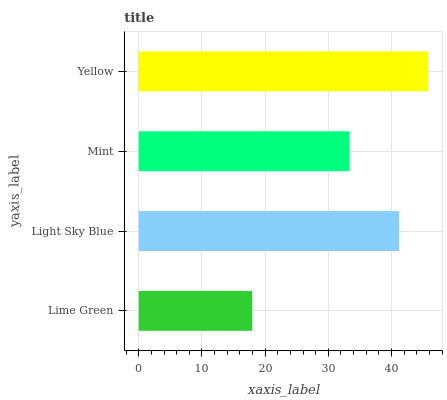Is Lime Green the minimum?
Answer yes or no. Yes. Is Yellow the maximum?
Answer yes or no. Yes. Is Light Sky Blue the minimum?
Answer yes or no. No. Is Light Sky Blue the maximum?
Answer yes or no. No. Is Light Sky Blue greater than Lime Green?
Answer yes or no. Yes. Is Lime Green less than Light Sky Blue?
Answer yes or no. Yes. Is Lime Green greater than Light Sky Blue?
Answer yes or no. No. Is Light Sky Blue less than Lime Green?
Answer yes or no. No. Is Light Sky Blue the high median?
Answer yes or no. Yes. Is Mint the low median?
Answer yes or no. Yes. Is Yellow the high median?
Answer yes or no. No. Is Yellow the low median?
Answer yes or no. No. 